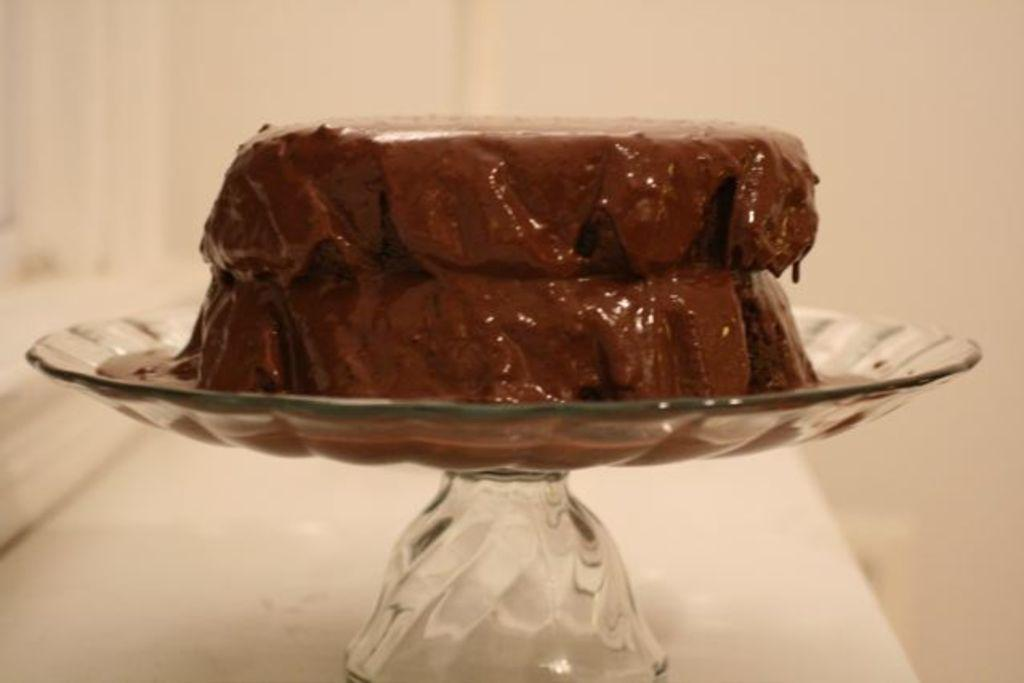What is on the glass plate in the image? There is a chocolate cake on the plate. Can you describe the main subject of the image? The main subject of the image is a glass plate with a chocolate cake on it. What can be seen in the background of the image? The background of the image is blurry. What type of sock is hanging from the plane in the image? There is no plane or sock present in the image. What stage of development is the chocolate cake in the image? The provided facts do not give information about the stage of development of the chocolate cake. 